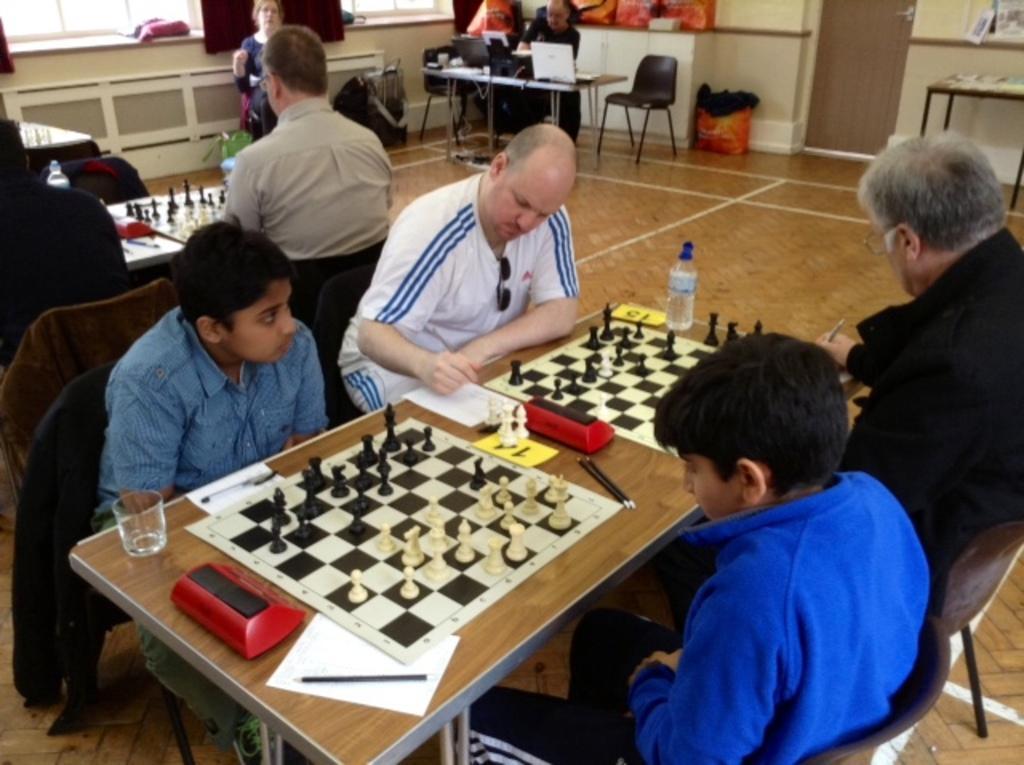In one or two sentences, can you explain what this image depicts? The picture is taken in the closed room and there are so many people sitting on the chairs and playing chess in front of them on the tables, on the table there are glasses,water bottle and paper,pens. At the right corner of the picture there is one table, behind the table there is one wall and door and chairs and tables and laptop on the table. On the right corner of the picture there is a wall and windows. 